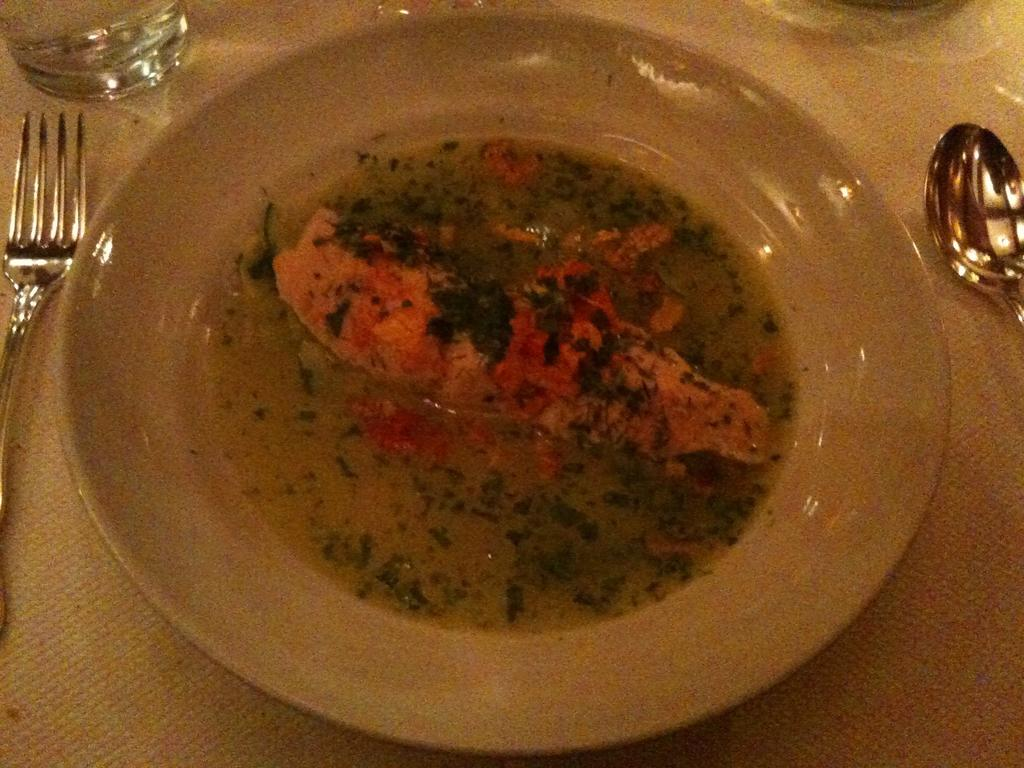What is on the plate that is visible in the image? There is food on a plate in the image. What utensils are present in the image? There is a spoon and a fork in the image. What is the beverage container in the image? There is a glass in the image. Where are all of these items located? All of these items are on a table. What type of creature can be seen using the calculator in the image? There is no creature or calculator present in the image. 